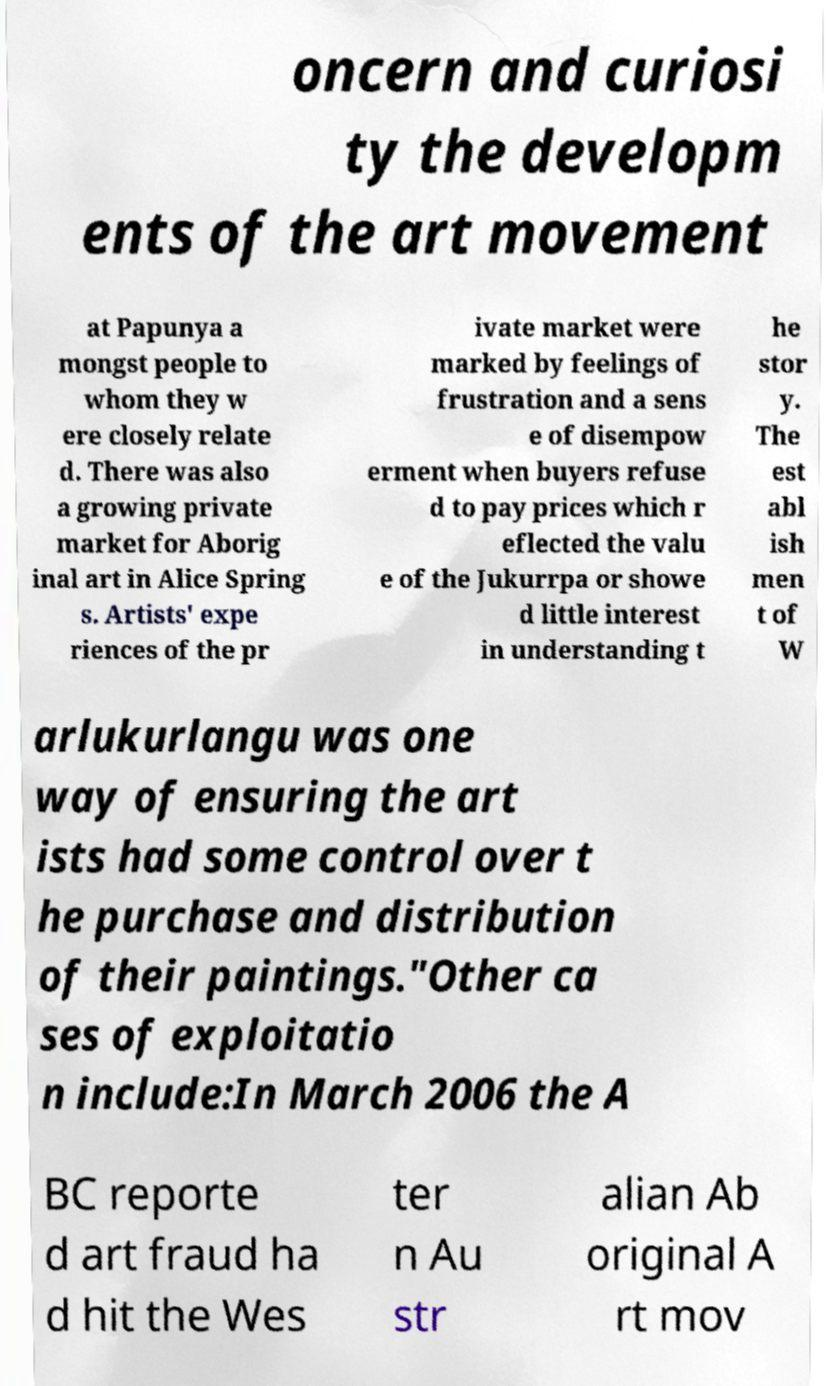Can you accurately transcribe the text from the provided image for me? oncern and curiosi ty the developm ents of the art movement at Papunya a mongst people to whom they w ere closely relate d. There was also a growing private market for Aborig inal art in Alice Spring s. Artists' expe riences of the pr ivate market were marked by feelings of frustration and a sens e of disempow erment when buyers refuse d to pay prices which r eflected the valu e of the Jukurrpa or showe d little interest in understanding t he stor y. The est abl ish men t of W arlukurlangu was one way of ensuring the art ists had some control over t he purchase and distribution of their paintings."Other ca ses of exploitatio n include:In March 2006 the A BC reporte d art fraud ha d hit the Wes ter n Au str alian Ab original A rt mov 